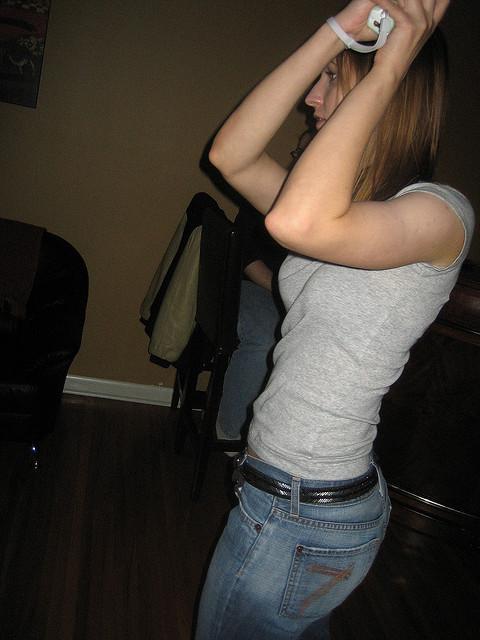How many thumbs are visible?
Give a very brief answer. 0. How many people are there?
Give a very brief answer. 1. 